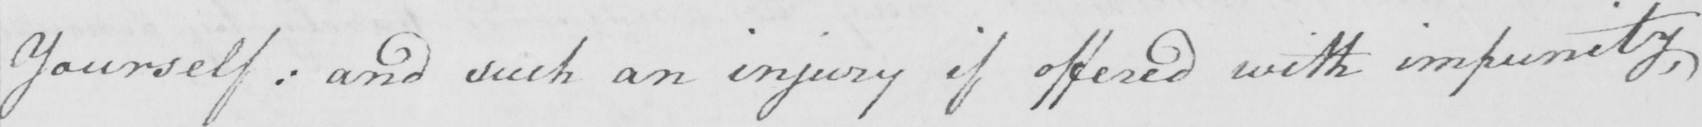What does this handwritten line say? Yourself :  and such an injury if offered with impunity , 